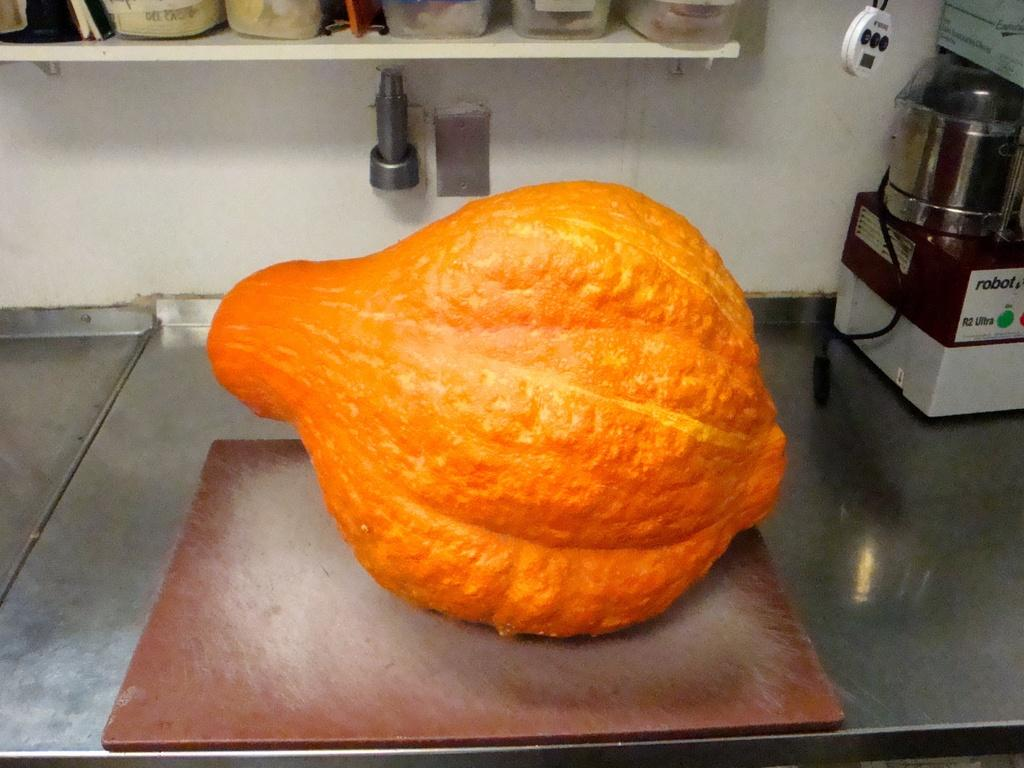<image>
Give a short and clear explanation of the subsequent image. A gourd sits on a counter near a Robot brand appliance. 